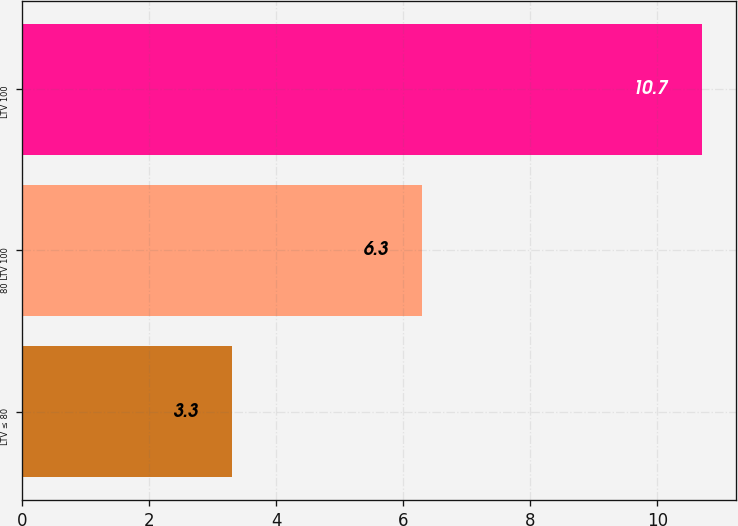<chart> <loc_0><loc_0><loc_500><loc_500><bar_chart><fcel>LTV ≤ 80<fcel>80 LTV 100<fcel>LTV 100<nl><fcel>3.3<fcel>6.3<fcel>10.7<nl></chart> 